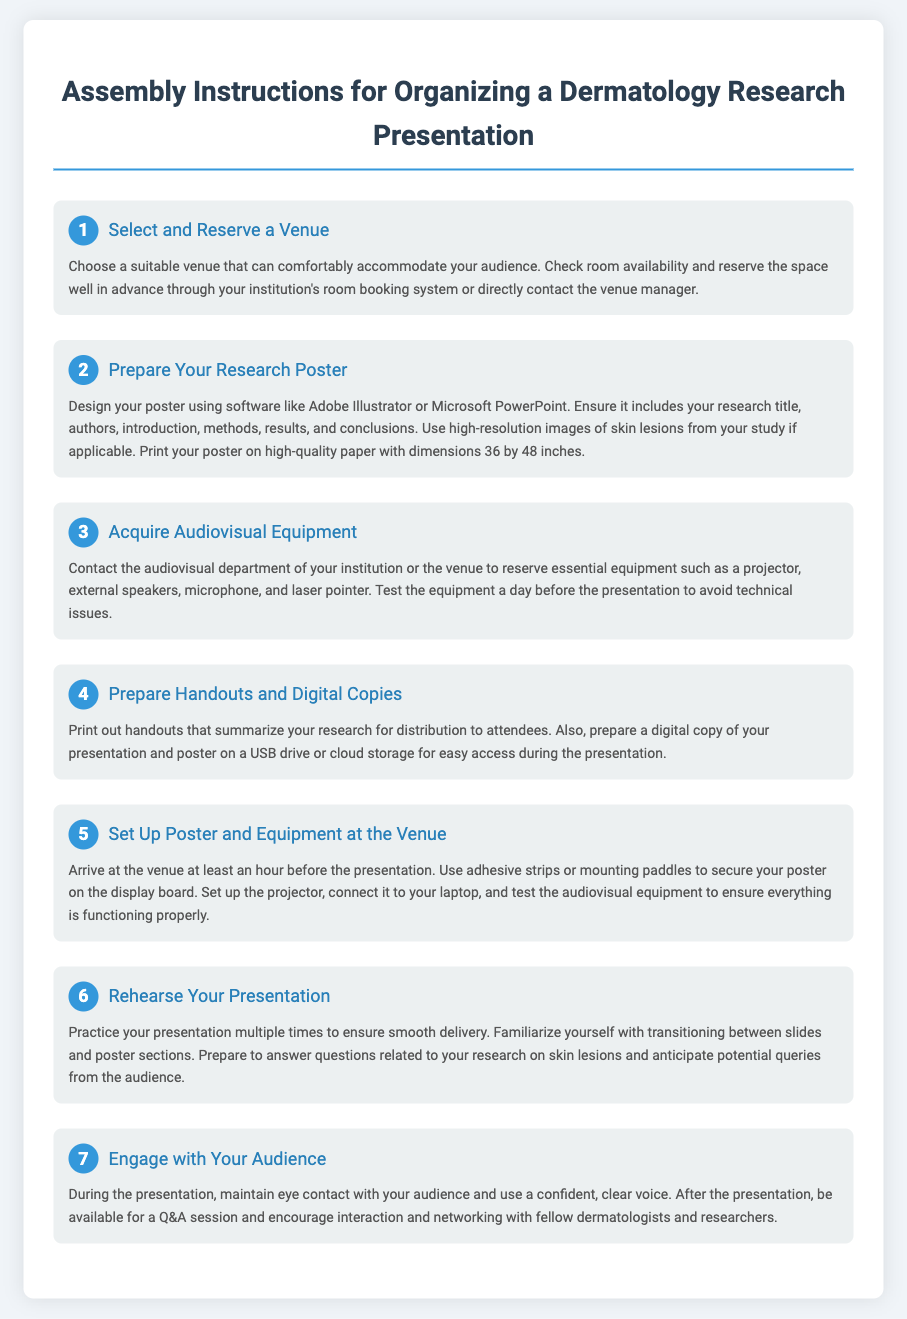What is the title of the presentation instructions? The title of the presentation instructions is stated at the top of the document.
Answer: Assembly Instructions for Organizing a Dermatology Research Presentation What are the dimensions for the research poster? The document specifies the dimensions for the poster in the section about preparing the research poster.
Answer: 36 by 48 inches How many steps are there in the assembly instructions? The number of steps is indicated in the introduction "7 steps" which outlines the overall assembly process.
Answer: 7 What is the first step in organizing the presentation? The first step outlined in the instructions describes the initial action needed for organizing the presentation.
Answer: Select and Reserve a Venue How long before the presentation should you arrive at the venue? The time to arrive at the venue is mentioned in the step regarding setting up.
Answer: At least an hour What should you do to test audiovisual equipment? The document describes the action required to ensure everything is functioning properly before the presentation.
Answer: Test the equipment What should you prepare for distribution to attendees? The instructions mention items that should be ready for attendees in one of the steps.
Answer: Handouts What is emphasized during the presentation for audience engagement? The last step highlights a key aspect of presenting effectively to the audience.
Answer: Maintain eye contact 